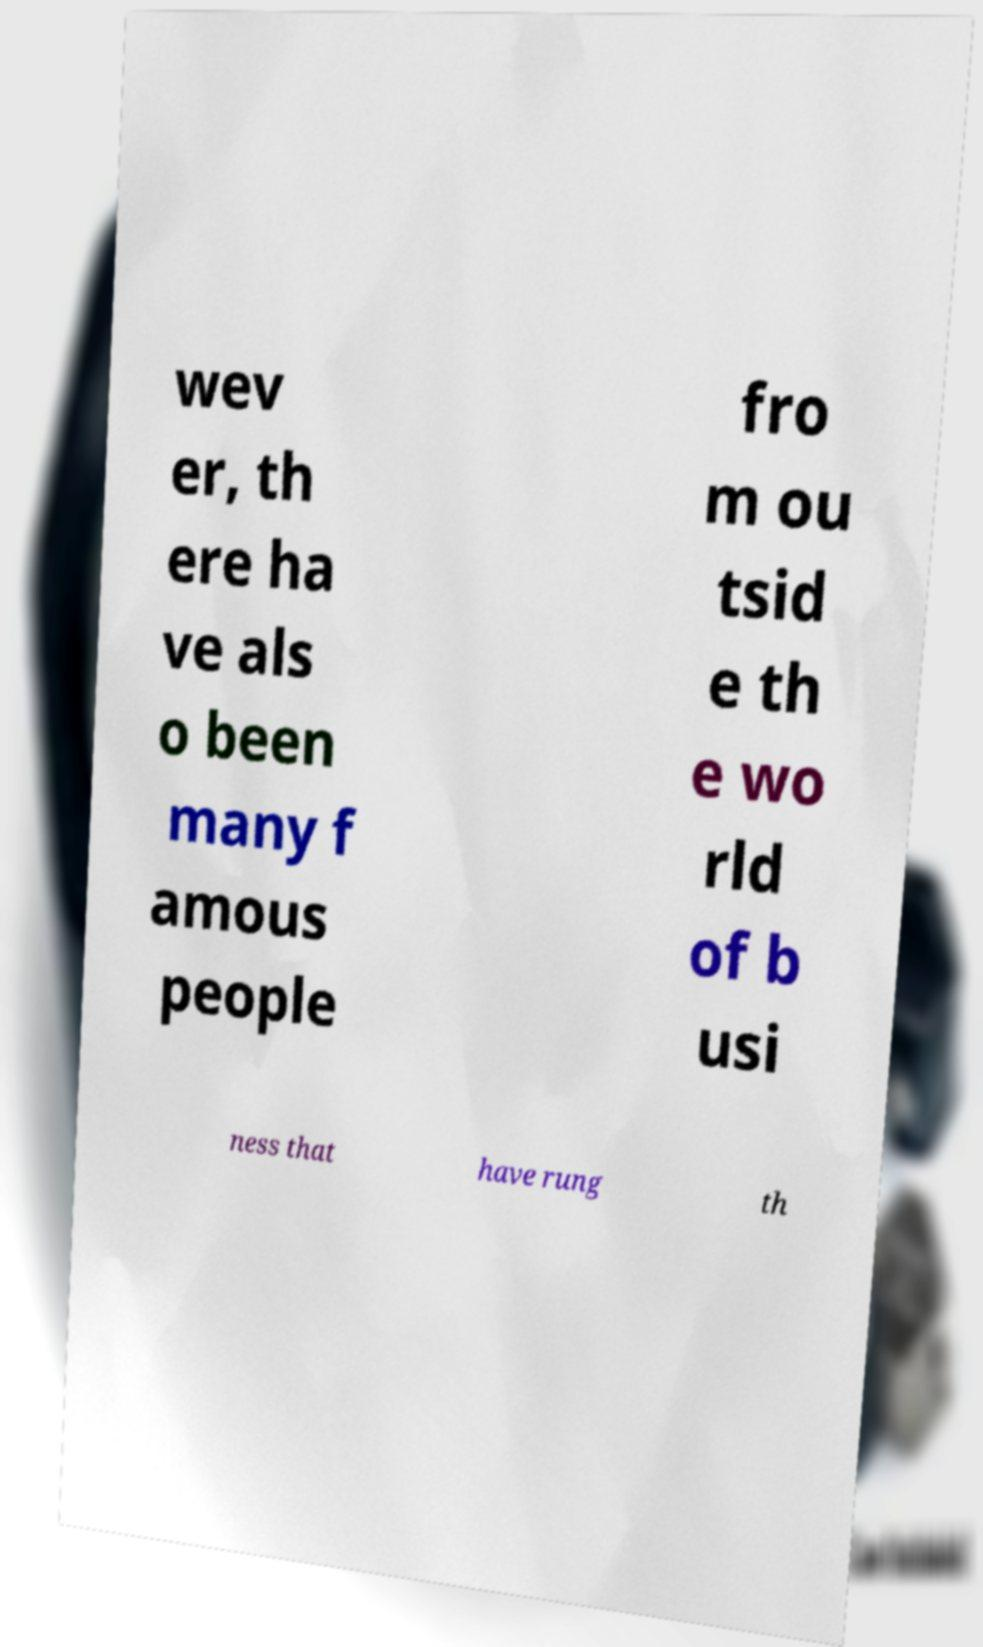Could you extract and type out the text from this image? wev er, th ere ha ve als o been many f amous people fro m ou tsid e th e wo rld of b usi ness that have rung th 